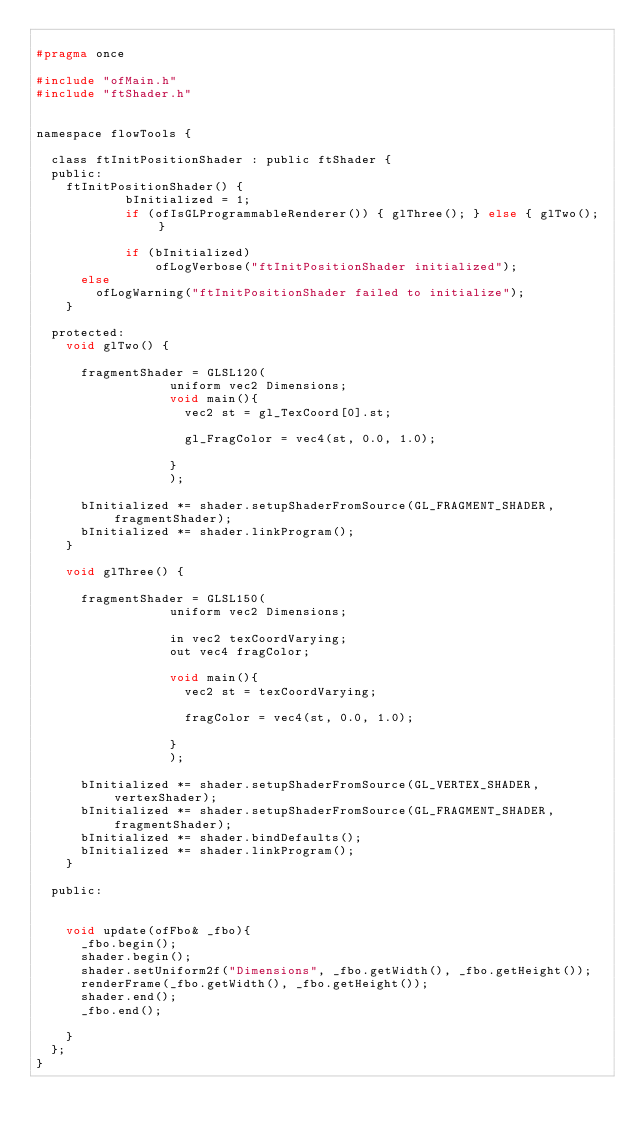Convert code to text. <code><loc_0><loc_0><loc_500><loc_500><_C_>
#pragma once

#include "ofMain.h"
#include "ftShader.h"


namespace flowTools {
	
	class ftInitPositionShader : public ftShader {
	public:
		ftInitPositionShader() {
            bInitialized = 1;
            if (ofIsGLProgrammableRenderer()) { glThree(); } else { glTwo(); }
			
            if (bInitialized)
                ofLogVerbose("ftInitPositionShader initialized");
			else
				ofLogWarning("ftInitPositionShader failed to initialize");
		}
		
	protected:
		void glTwo() {
			
			fragmentShader = GLSL120(
								  uniform vec2 Dimensions;
								  void main(){
									  vec2 st = gl_TexCoord[0].st;
									  
									  gl_FragColor = vec4(st, 0.0, 1.0);
									  
								  }
								  );
			
			bInitialized *= shader.setupShaderFromSource(GL_FRAGMENT_SHADER, fragmentShader);
			bInitialized *= shader.linkProgram();
		}
		
		void glThree() {
			
			fragmentShader = GLSL150(
								  uniform vec2 Dimensions;
								  
								  in vec2 texCoordVarying;
								  out vec4 fragColor;
								  
								  void main(){
									  vec2 st = texCoordVarying;
									  
									  fragColor = vec4(st, 0.0, 1.0);
									  
								  }
								  );
			
			bInitialized *= shader.setupShaderFromSource(GL_VERTEX_SHADER, vertexShader);
			bInitialized *= shader.setupShaderFromSource(GL_FRAGMENT_SHADER, fragmentShader);
			bInitialized *= shader.bindDefaults();
			bInitialized *= shader.linkProgram();
		}
		
	public:
		
		
		void update(ofFbo& _fbo){
			_fbo.begin();
			shader.begin();
			shader.setUniform2f("Dimensions", _fbo.getWidth(), _fbo.getHeight());
			renderFrame(_fbo.getWidth(), _fbo.getHeight());
			shader.end();
			_fbo.end();

		}
	};
}
</code> 